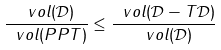Convert formula to latex. <formula><loc_0><loc_0><loc_500><loc_500>\frac { \ v o l ( \mathcal { D } ) } { \ v o l ( P P T ) } \leq \frac { \ v o l ( \mathcal { D } - T \mathcal { D } ) } { \ v o l ( \mathcal { D } ) }</formula> 